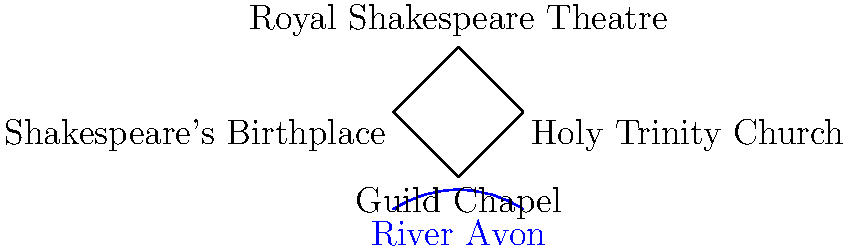Based on the simplified map of Stratford-upon-Avon's historic town center, which landmark forms the northernmost point of the quadrilateral formed by the four main attractions? To determine the northernmost point in the quadrilateral, we need to follow these steps:

1. Identify the four landmarks on the map:
   - Shakespeare's Birthplace
   - Royal Shakespeare Theatre
   - Holy Trinity Church
   - Guild Chapel

2. Visualize the quadrilateral formed by connecting these four points.

3. Analyze the relative positions of the landmarks:
   - Shakespeare's Birthplace is in the west
   - Royal Shakespeare Theatre is in the north
   - Holy Trinity Church is in the east
   - Guild Chapel is in the south

4. Compare the vertical positions of the landmarks:
   - The Royal Shakespeare Theatre is clearly positioned higher (more north) than the other three landmarks.

5. Conclude that the Royal Shakespeare Theatre forms the northernmost point of the quadrilateral.

This layout reflects the actual geographical arrangement of these landmarks in Stratford-upon-Avon's town center, with the Royal Shakespeare Theatre indeed being the northernmost of these four significant sites.
Answer: Royal Shakespeare Theatre 